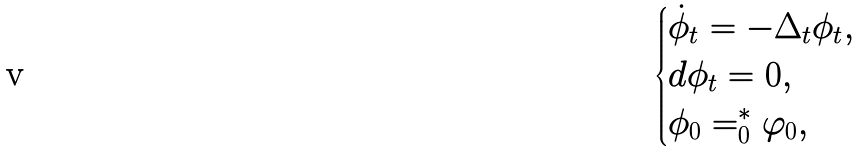<formula> <loc_0><loc_0><loc_500><loc_500>\begin{cases} \dot { \phi } _ { t } = - \Delta _ { t } \phi _ { t } , \\ d \phi _ { t } = 0 , \\ \phi _ { 0 } = ^ { * } _ { 0 } \varphi _ { 0 } , \end{cases}</formula> 